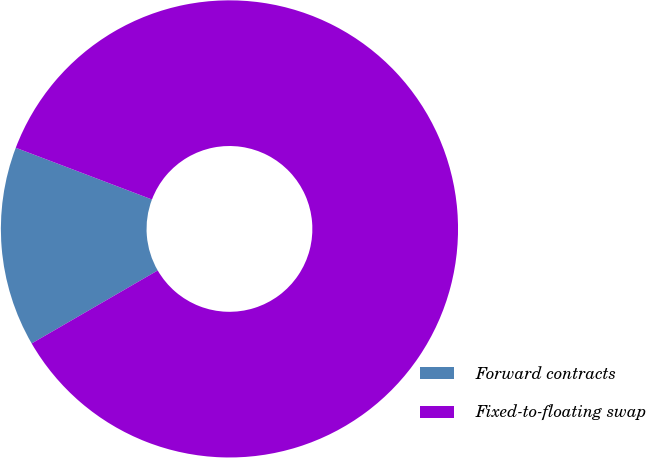Convert chart. <chart><loc_0><loc_0><loc_500><loc_500><pie_chart><fcel>Forward contracts<fcel>Fixed-to-floating swap<nl><fcel>14.13%<fcel>85.87%<nl></chart> 